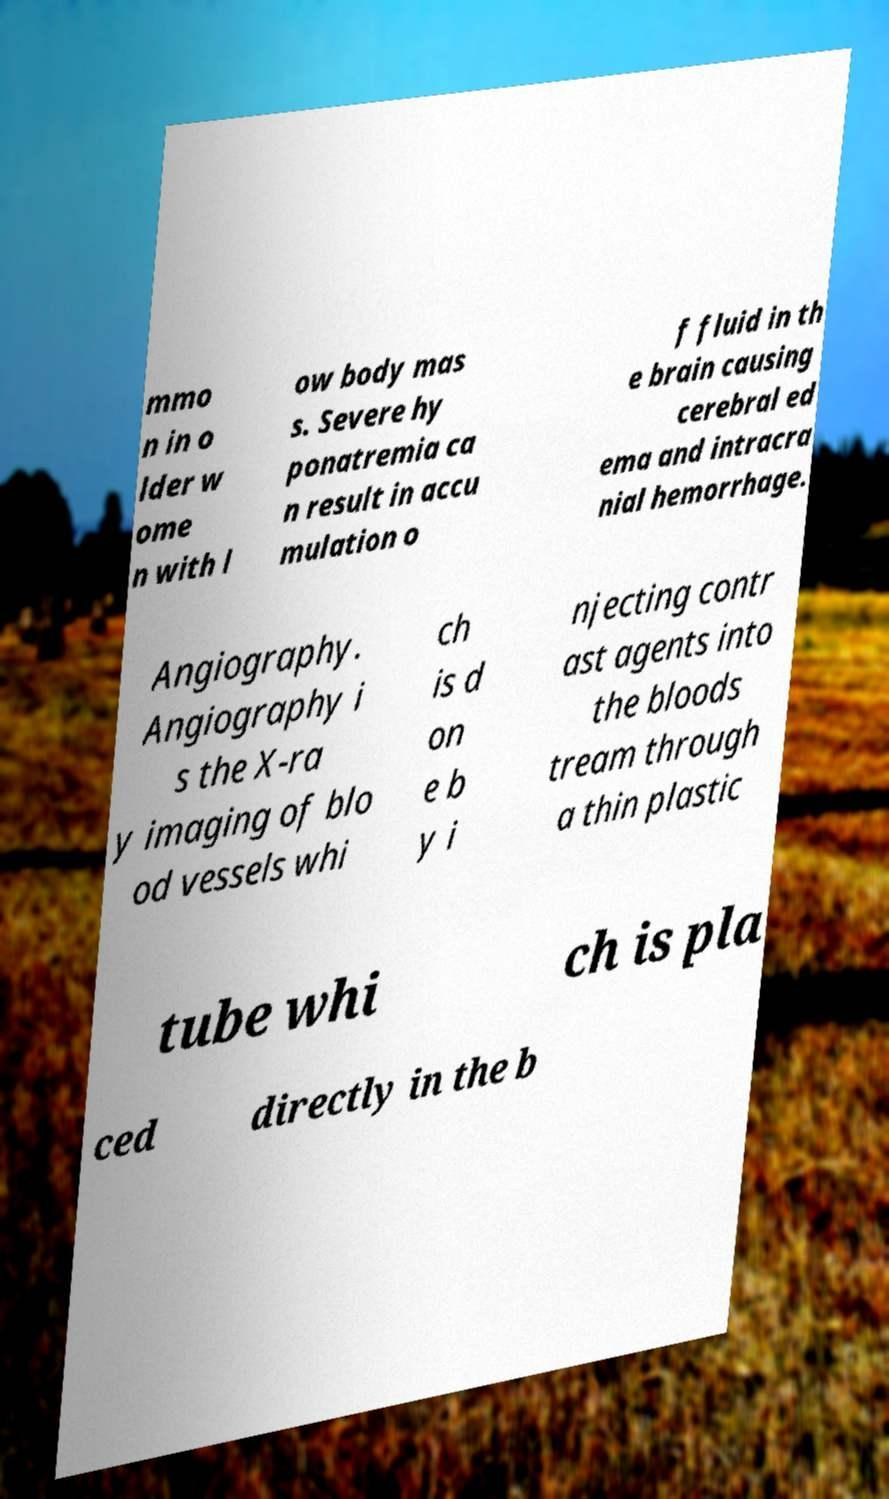Could you extract and type out the text from this image? mmo n in o lder w ome n with l ow body mas s. Severe hy ponatremia ca n result in accu mulation o f fluid in th e brain causing cerebral ed ema and intracra nial hemorrhage. Angiography. Angiography i s the X-ra y imaging of blo od vessels whi ch is d on e b y i njecting contr ast agents into the bloods tream through a thin plastic tube whi ch is pla ced directly in the b 